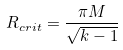Convert formula to latex. <formula><loc_0><loc_0><loc_500><loc_500>R _ { c r i t } = \frac { \pi M } { \sqrt { k - 1 } }</formula> 